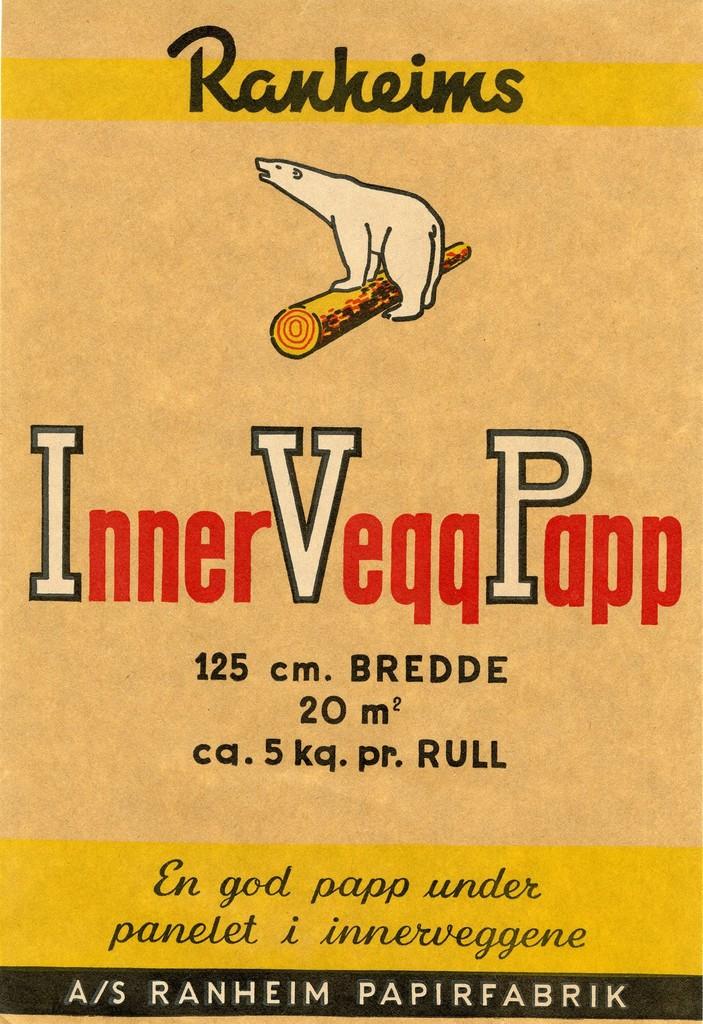What word is on the top of the bear?
Make the answer very short. Ranheims. What is the word at the lower end of the picture?
Your answer should be very brief. Papirfabrik. 